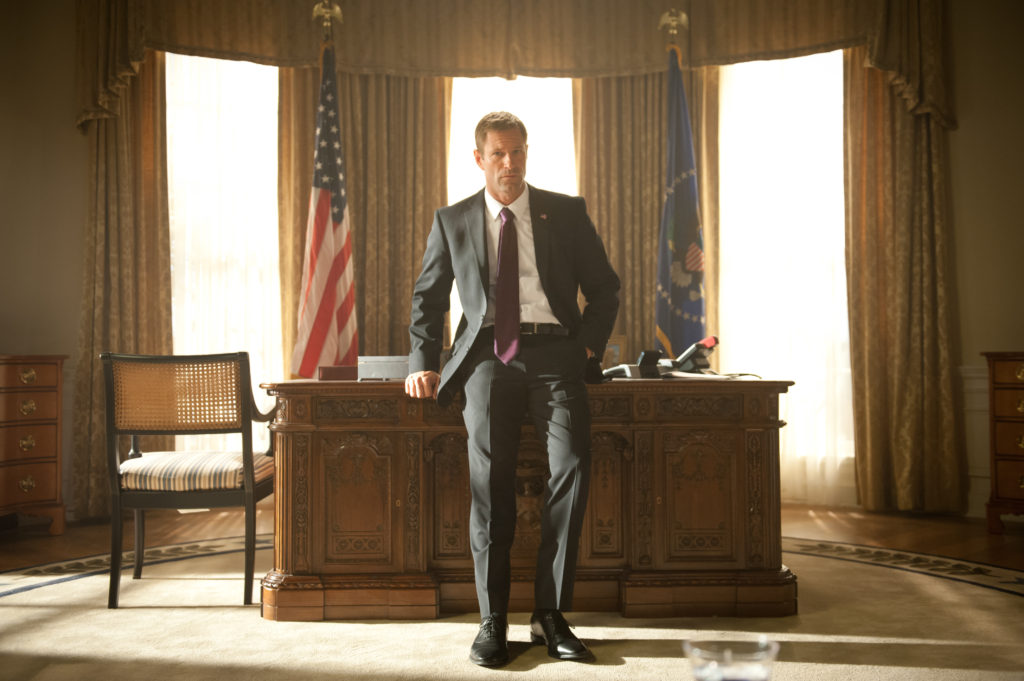If the room could speak, what stories would it tell? If this room could speak, it would narrate tales of power, decision-making, and historic moments. It would tell stories of intense discussions during times of national crisis, moments of triumph and joy as pivotal policies were enacted, and the silent contemplations of a leader bearing the weight of an entire nation. The room would recall the whispering secrets exchanged during confidential briefings, the solemn vows taken, and the tears shed in times of loss. It might reflect on the changing world outside its windows over the years, remembering the different personalities that have paced its floors, each leaving an indelible mark on history. The walls would resonate with the echoes of speeches that inspired hope, decisions that shaped futures, and the constant hum of service to the public good. 